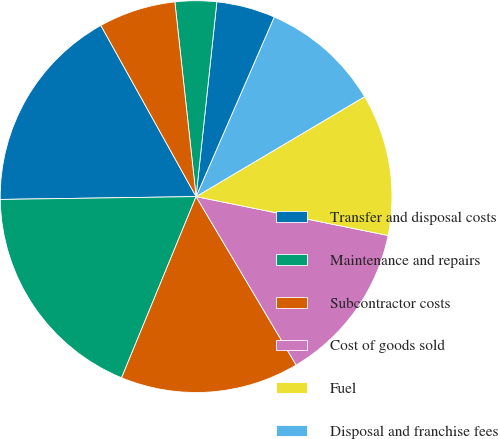Convert chart to OTSL. <chart><loc_0><loc_0><loc_500><loc_500><pie_chart><fcel>Transfer and disposal costs<fcel>Maintenance and repairs<fcel>Subcontractor costs<fcel>Cost of goods sold<fcel>Fuel<fcel>Disposal and franchise fees<fcel>Landfill operating costs<fcel>Risk management<fcel>Other<nl><fcel>17.15%<fcel>18.56%<fcel>14.74%<fcel>13.29%<fcel>11.7%<fcel>9.95%<fcel>4.84%<fcel>3.42%<fcel>6.35%<nl></chart> 